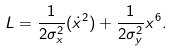Convert formula to latex. <formula><loc_0><loc_0><loc_500><loc_500>L = \frac { 1 } { 2 \sigma _ { x } ^ { 2 } } ( \dot { x } ^ { 2 } ) + \frac { 1 } { 2 \sigma _ { y } ^ { 2 } } x ^ { 6 } .</formula> 